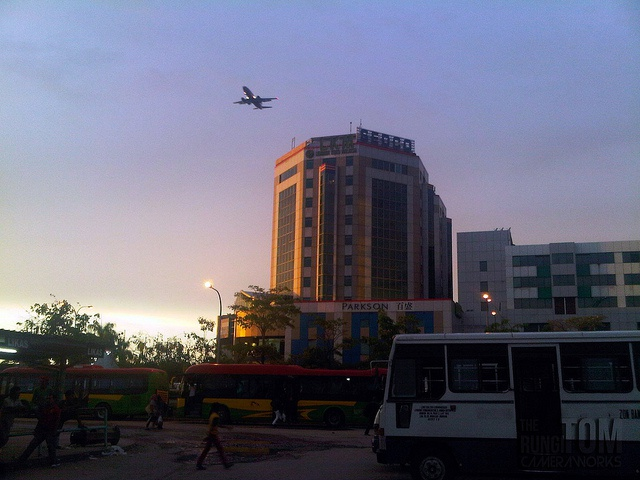Describe the objects in this image and their specific colors. I can see bus in darkgray, black, darkblue, and gray tones, bus in darkgray, black, maroon, and gray tones, bus in darkgray, black, and maroon tones, people in black and darkgray tones, and people in black, maroon, and darkgray tones in this image. 